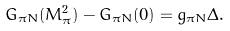Convert formula to latex. <formula><loc_0><loc_0><loc_500><loc_500>G _ { \pi N } ( M _ { \pi } ^ { 2 } ) - G _ { \pi N } ( 0 ) = g _ { \pi N } \Delta .</formula> 